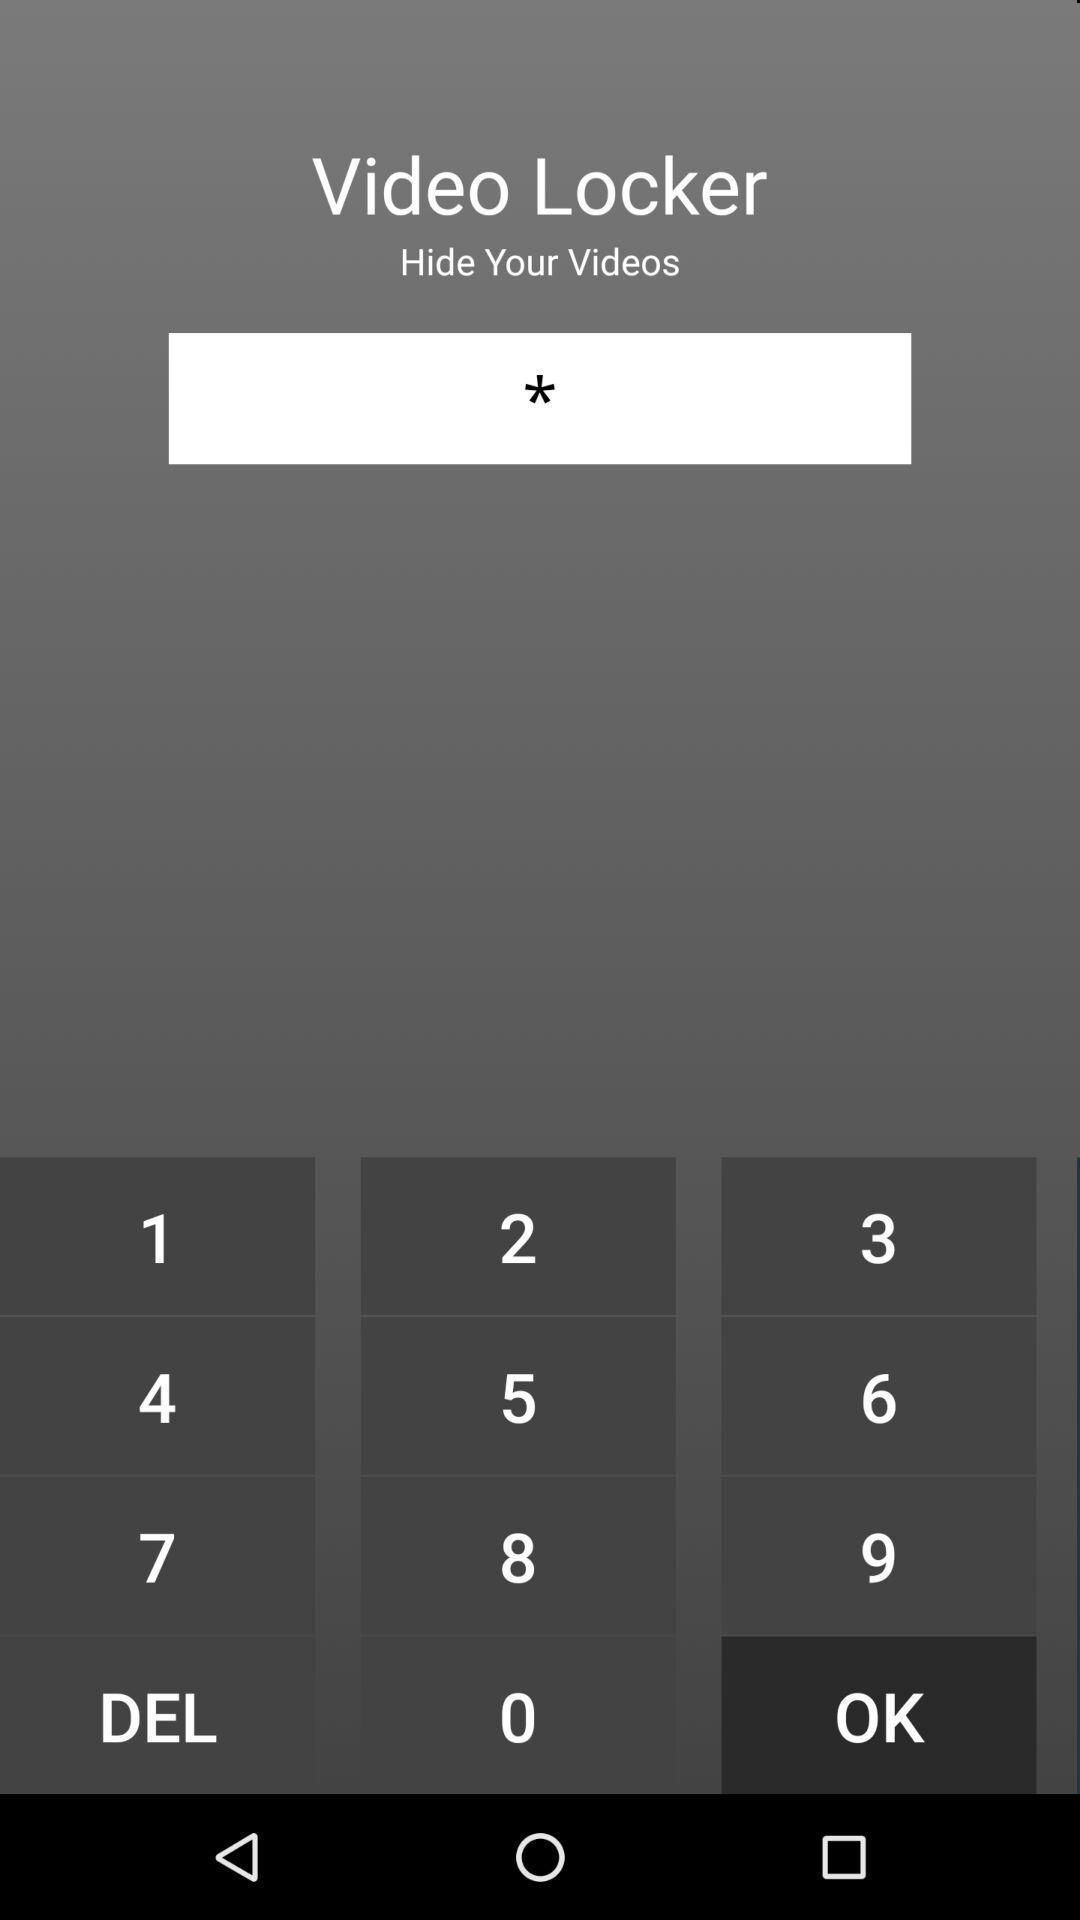Provide a detailed account of this screenshot. Screen shows keypad to lock the application. 